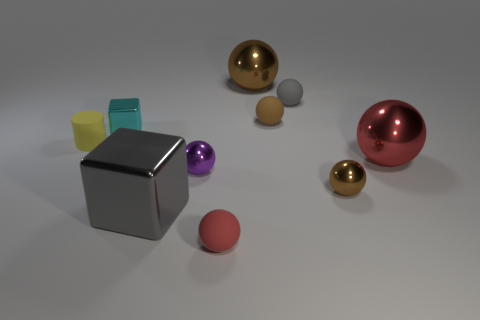Does the red matte thing have the same shape as the tiny cyan thing?
Keep it short and to the point. No. Are there any cyan things that are on the left side of the matte object that is on the left side of the large object to the left of the tiny red rubber thing?
Your response must be concise. No. What number of large shiny objects are the same color as the small shiny cube?
Provide a short and direct response. 0. What is the shape of the purple shiny object that is the same size as the red matte sphere?
Provide a succinct answer. Sphere. Are there any tiny brown rubber objects on the right side of the red shiny ball?
Offer a terse response. No. Do the brown rubber ball and the gray sphere have the same size?
Keep it short and to the point. Yes. What is the shape of the red thing behind the big gray metal cube?
Your answer should be compact. Sphere. Is there a cyan matte sphere that has the same size as the gray rubber sphere?
Give a very brief answer. No. What is the material of the brown object that is the same size as the gray block?
Offer a very short reply. Metal. There is a brown ball in front of the tiny cyan block; what is its size?
Offer a terse response. Small. 